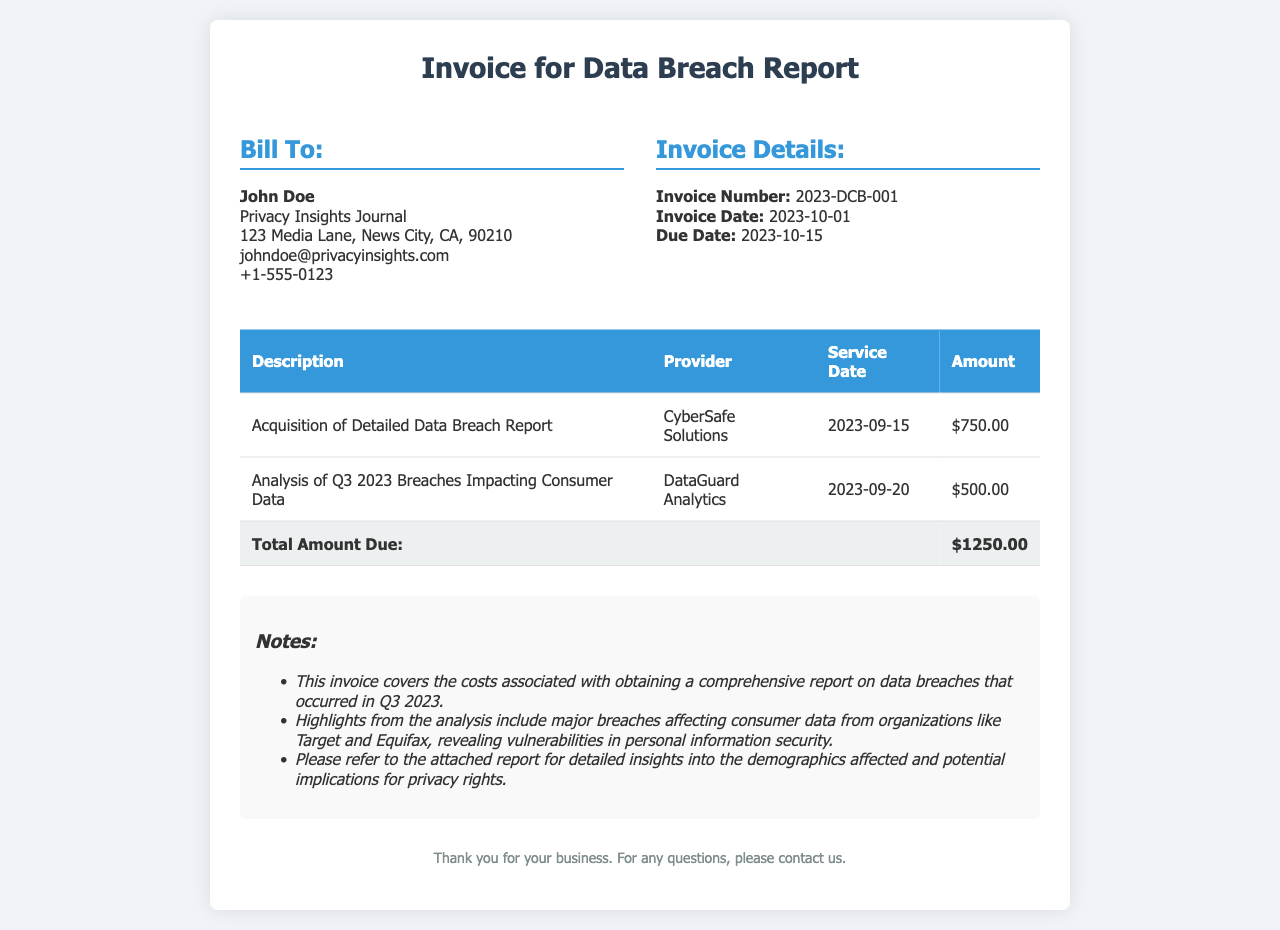What is the invoice number? The invoice number is presented in the invoice details section.
Answer: 2023-DCB-001 Who was billed for the report? The invoice shows the information of the person who is billed for the report.
Answer: John Doe What is the total amount due? The total amount due is presented at the bottom of the invoice table.
Answer: $1250.00 Which provider is associated with the data breach report acquisition? The provider is listed in the table corresponding to the description of the service.
Answer: CyberSafe Solutions What was the service date for the analysis of Q3 2023 breaches? The service date can be found in the corresponding row for the analysis service.
Answer: 2023-09-20 What type of report was acquired? The type of report is specified in the description section of the invoice.
Answer: Detailed Data Breach Report What did the analysis focus on? The analysis is summarized in the notes section of the invoice.
Answer: Breaches Impacting Consumer Data What is the due date for this invoice? The due date is found in the invoice details section.
Answer: 2023-10-15 What was the cost for the analysis of breaches? The cost for analysis can be found in the corresponding row of the invoice table.
Answer: $500.00 